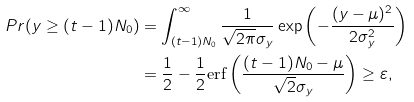<formula> <loc_0><loc_0><loc_500><loc_500>P r ( y \geq ( t - 1 ) N _ { 0 } ) & = \int _ { ( t - 1 ) N _ { 0 } } ^ { \infty } \frac { 1 } { \sqrt { 2 \pi } \sigma _ { y } } \exp \left ( - \frac { ( y - \mu ) ^ { 2 } } { 2 \sigma _ { y } ^ { 2 } } \right ) \\ & = \frac { 1 } { 2 } - \frac { 1 } { 2 } \text {erf} \left ( \frac { ( t - 1 ) N _ { 0 } - \mu } { \sqrt { 2 } \sigma _ { y } } \right ) \geq \varepsilon ,</formula> 